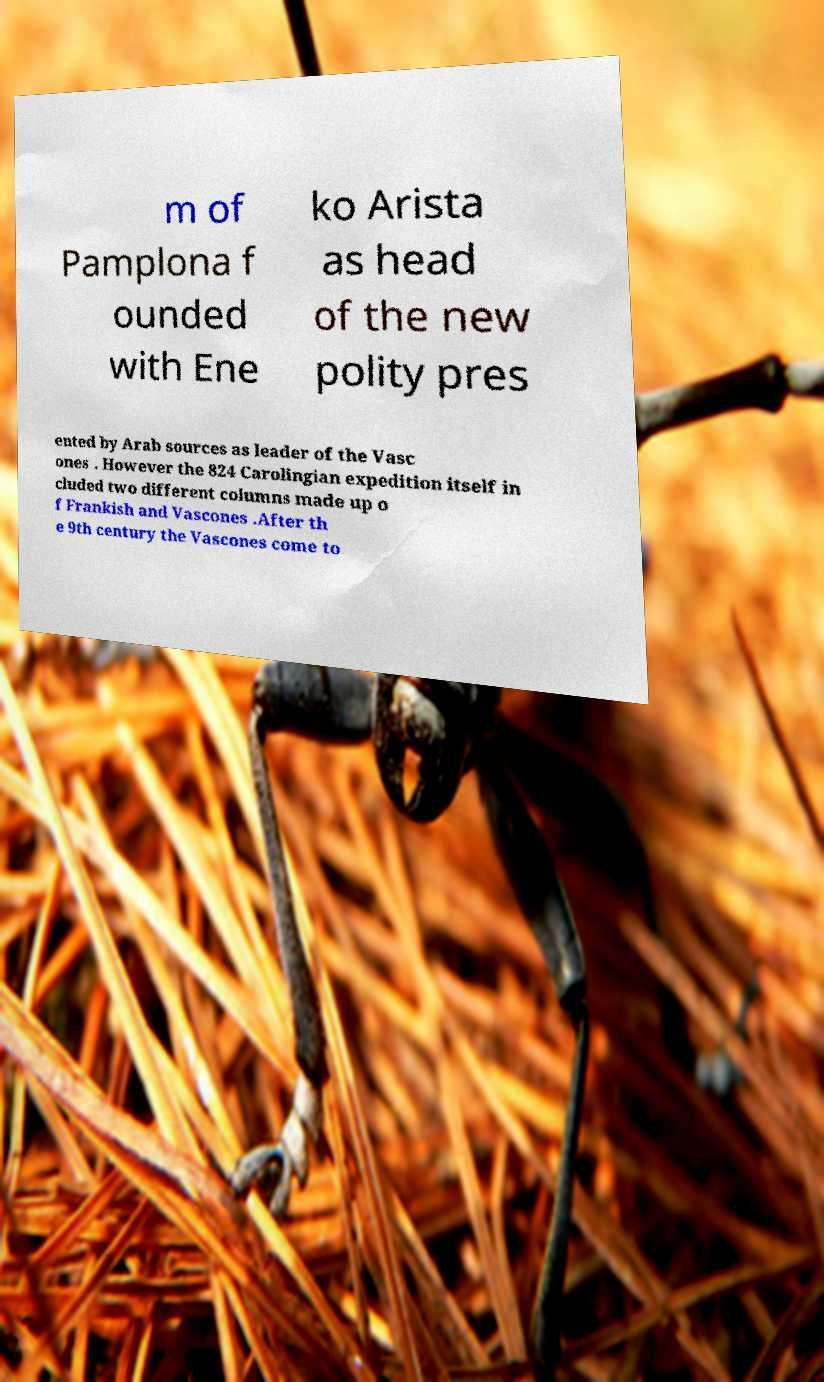For documentation purposes, I need the text within this image transcribed. Could you provide that? m of Pamplona f ounded with Ene ko Arista as head of the new polity pres ented by Arab sources as leader of the Vasc ones . However the 824 Carolingian expedition itself in cluded two different columns made up o f Frankish and Vascones .After th e 9th century the Vascones come to 